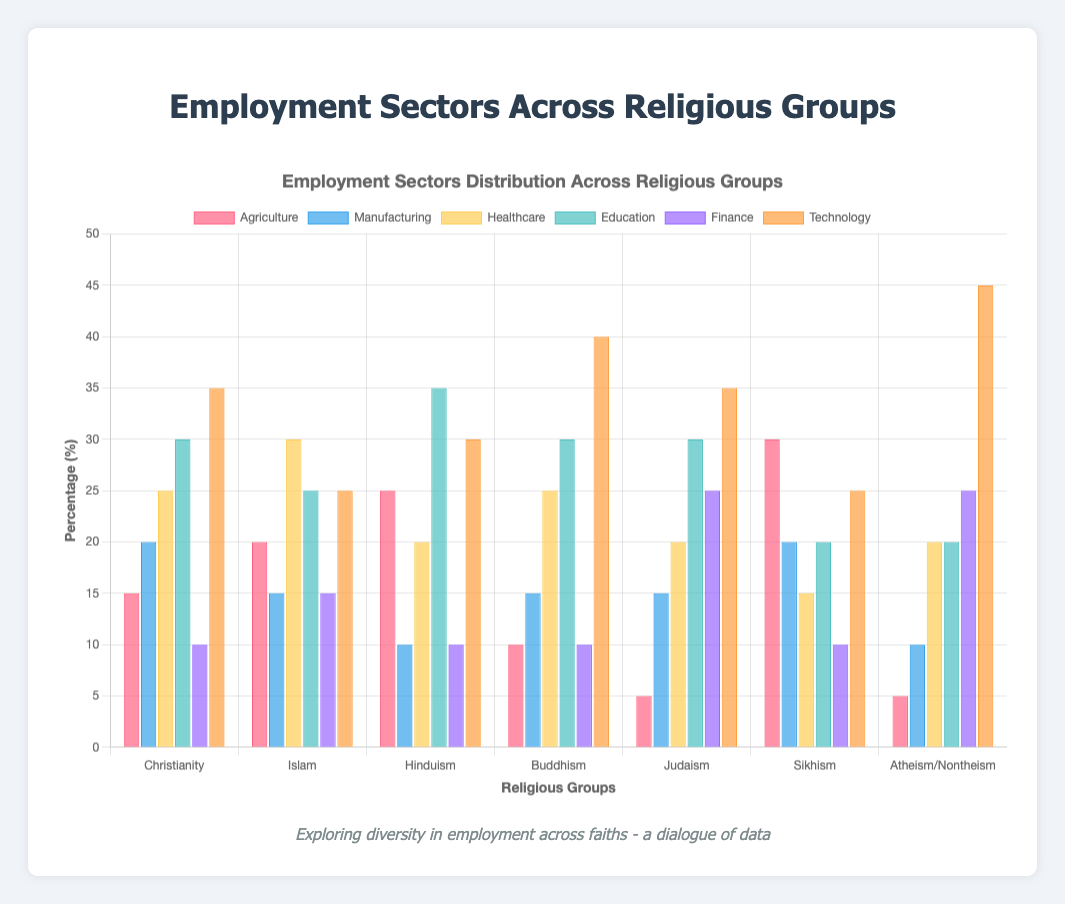Which religious group has the highest percentage in the Technology sector? Look at the bars representing the Technology sector for each religious group. The highest bar belongs to the Atheism/Nontheism group.
Answer: Atheism/Nontheism How does the percentage of people employed in Agriculture compare between Christianity and Sikhism? Find the bars for Agriculture for both Christianity (15%) and Sikhism (30%). Sikhism has a higher percentage than Christianity.
Answer: Sikhism is higher Which two religious groups have the same percentage of people employed in the Education sector? Look at the bars for Education for all religious groups. Christianity, Buddhism, and Judaism have the same percentage (30%).
Answer: Christianity, Buddhism, and Judaism What's the combined percentage of people employed in Healthcare and Finance for Judaism? Judaism has 20% in Healthcare and 25% in Finance. Summing these values gives 20 + 25.
Answer: 45% Which sectors are most dominant for the Hinduism group, and what are their percentages? Identify the tallest bars for the Hinduism group. The most dominant sectors are Education (35%) and Technology (30%).
Answer: Education (35%), Technology (30%) What is the difference in percentage between the highest and lowest employment sectors for Buddhism? For Buddhism, the highest percentage is in Technology (40%) and the lowest is in Agriculture (10%). The difference is 40 - 10.
Answer: 30% Which religious group has the lowest percentage in the Agriculture sector, and what is it? Look at the bars for Agriculture across all groups. The lowest percentage is for Judaism at 5%.
Answer: Judaism (5%) In which sector does Islam have the highest percentage of employment, and what is this percentage? Look at the bars for the Islam group across all sectors. The highest percentage is in Healthcare (30%).
Answer: Healthcare (30%) Which sector has the least variation in employment percentages across all religious groups? Compare the bars for each sector across all groups. Finance has the least variation with values mostly around 10%, 15%, and 25%.
Answer: Finance What is the average percentage of people employed in Manufacturing for all groups? Sum the percentages of Manufacturing for all groups and divide by the number of groups (20+15+10+15+15+20+10) / 7. Calculate (20 + 15 + 10 + 15 + 15 + 20 + 10) = 105, then average = 105 / 7.
Answer: 15% 